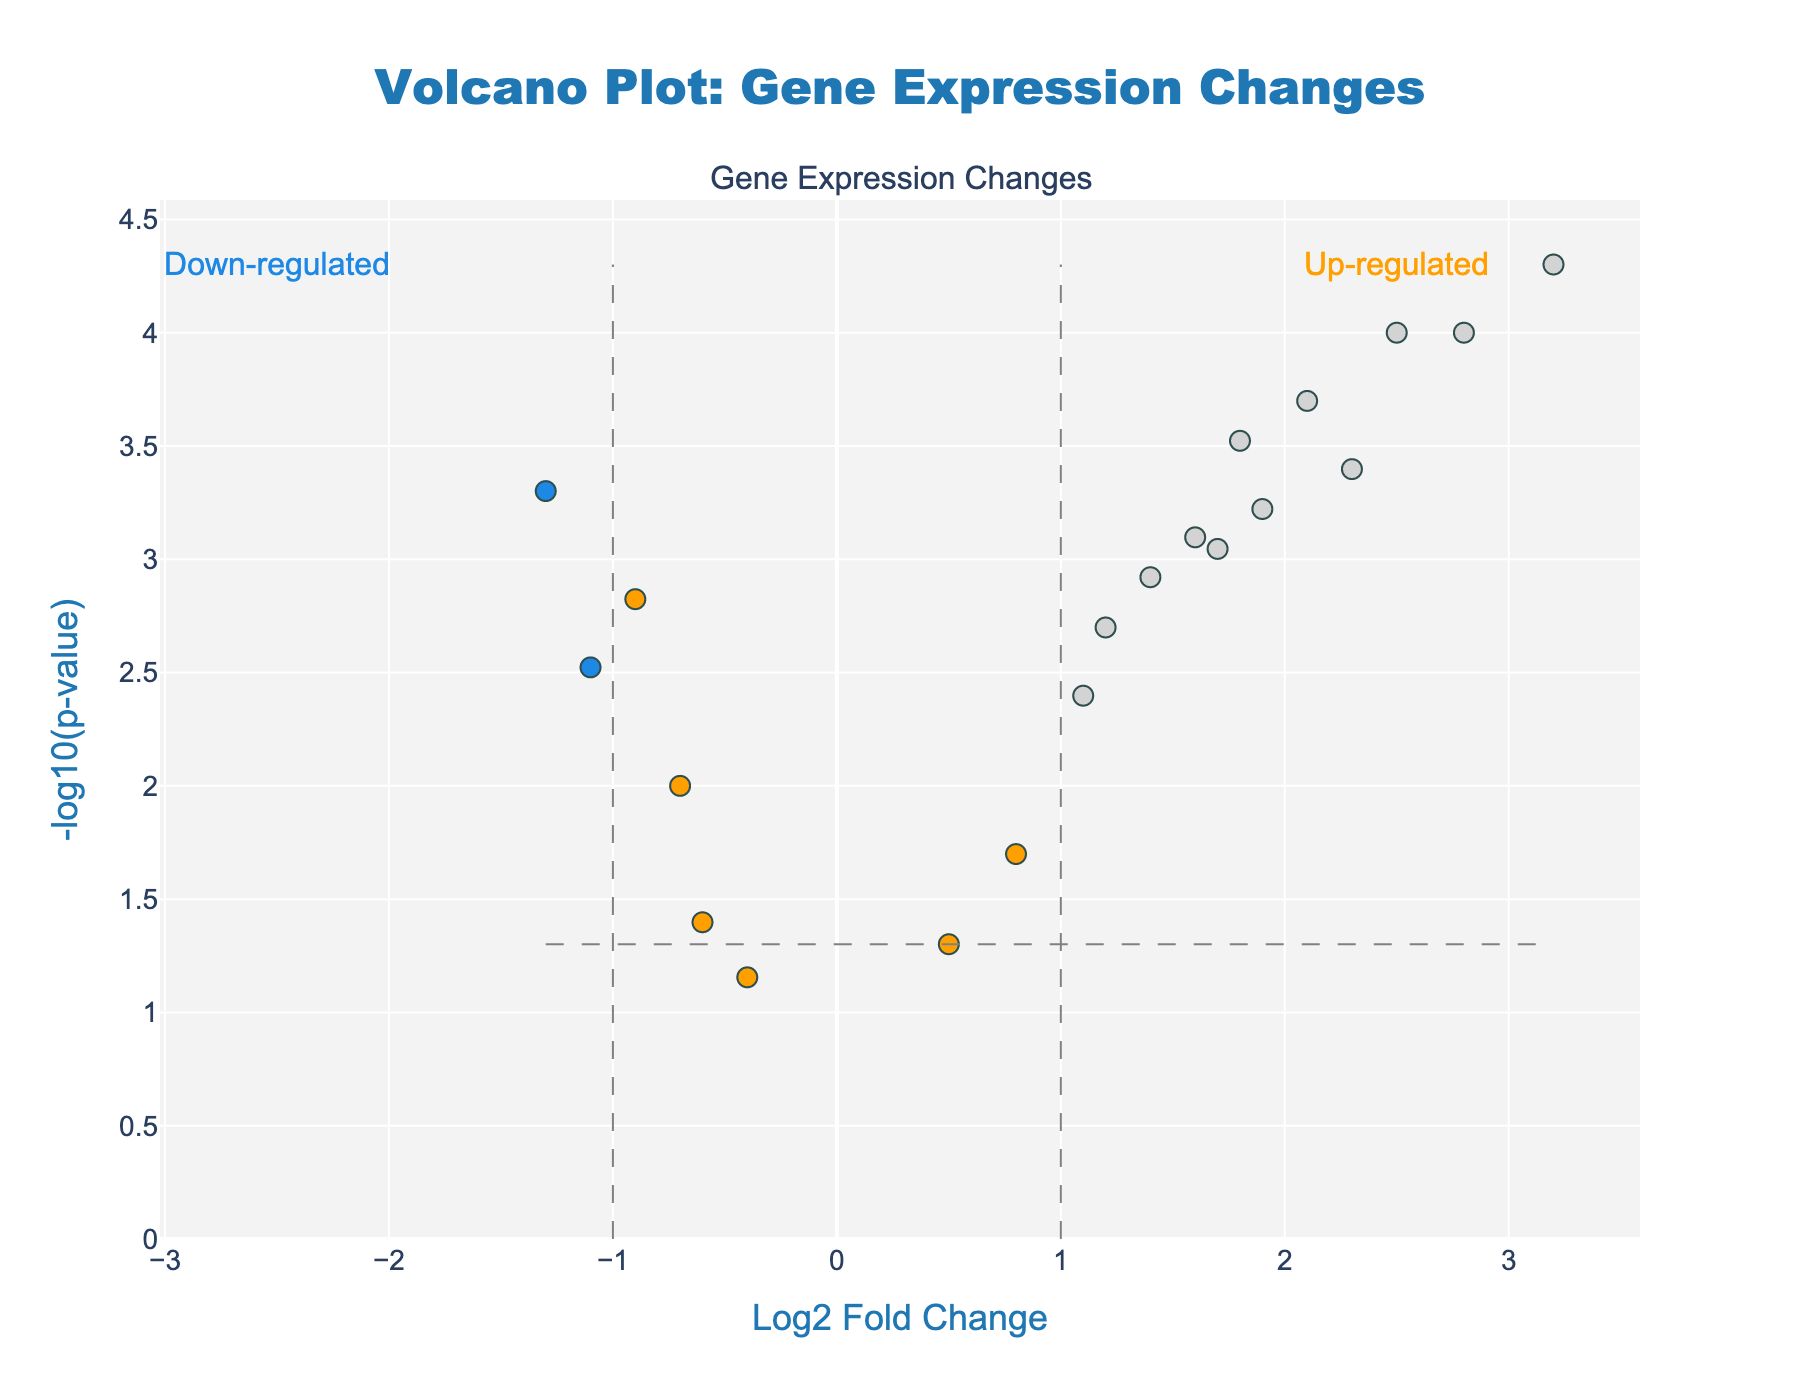What is the title of the plot? The title of the plot is displayed at the top of the figure. It reads, "Volcano Plot: Gene Expression Changes".
Answer: Volcano Plot: Gene Expression Changes What are the axes titles? The x-axis title is "Log2 Fold Change" and the y-axis title is "-log10(p-value)". These titles are displayed along the respective axes.
Answer: Log2 Fold Change; -log10(p-value) How many genes are up-regulated based on both thresholds? Up-regulated genes are marked with a specific color (orange) and have Log2FoldChange ≥ 1 and PValue < 0.05. Count the points meeting these criteria.
Answer: 8 How many genes are significantly down-regulated? Down-regulated genes are marked with a specific color (blue) and have Log2FoldChange ≤ -1 and PValue < 0.05. Count the points meeting these criteria.
Answer: 3 Which gene has the highest Log2 fold change? Identify the point positioned furthest right on the x-axis. The gene associated with this point has the highest Log2 fold change.
Answer: CYP1A1 What is the p-value threshold used in the plot? The plot uses a horizontal dashed line indicating the p-value threshold. This line appears where -log10(p-value) equals 1.3, corresponding to a p-value of 0.05.
Answer: 0.05 Which gene is represented by the point at (Log2FoldChange = 1.8, -log10(p-value) = 3.5229)? Locate the point at these coordinates and refer to the hover text information associated with it. The gene is DNAJB1.
Answer: DNAJB1 Are there any genes with a log fold change between -1 and 1 that are significant? Significant genes are those with -log10(p-value) ≥ 1.3. Check the points in the range -1 < Log2FoldChange < 1 to see if any meet this criteria.
Answer: Yes, there are some (like PRDX1, etc.) What is the log2 fold change of HMOX1? Cross-reference HMOX1 on the plot with its x-coordinate (Log2FoldChange). HMOX1 has Log2FoldChange = 2.1.
Answer: 2.1 Which gene is at (Log2FoldChange = -1.1, -log10(p-value) = 2.5229)? Locate the point at these coordinates and use the text information associated with it to identify the gene. The gene is GSTA1.
Answer: GSTA1 